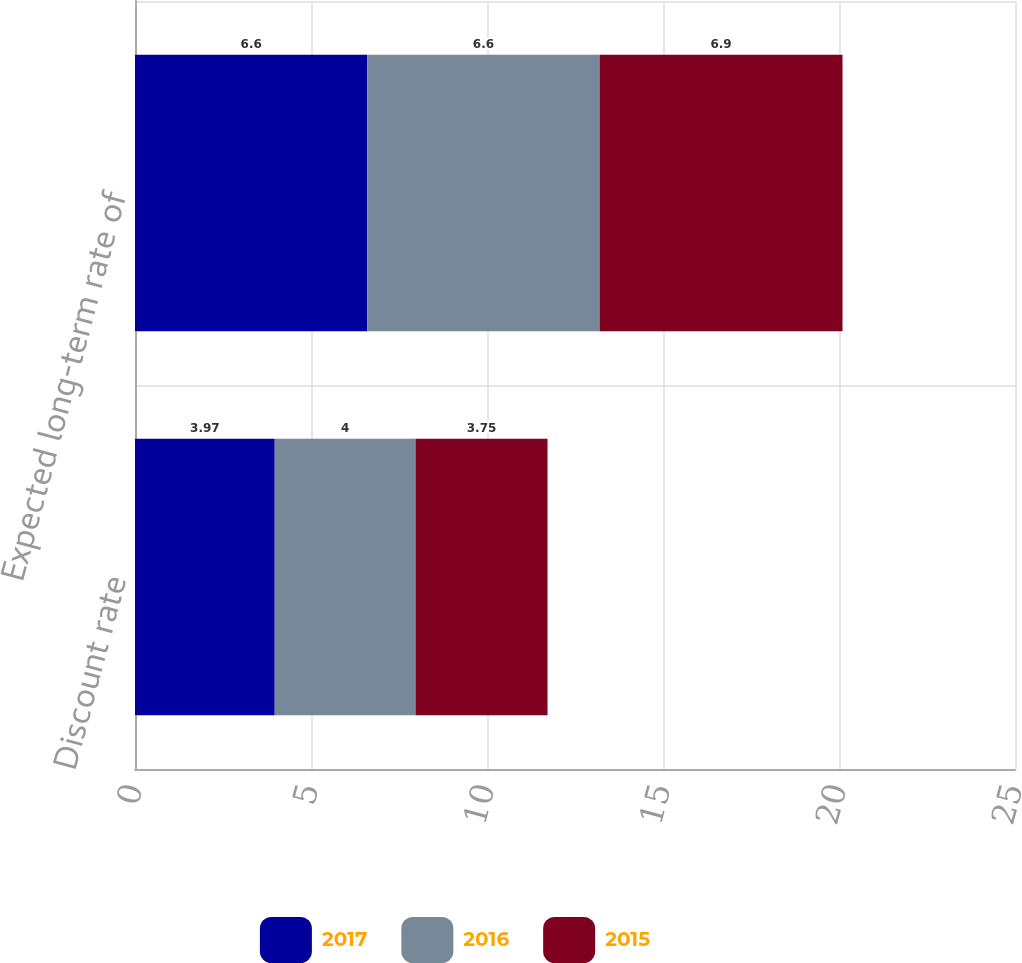Convert chart. <chart><loc_0><loc_0><loc_500><loc_500><stacked_bar_chart><ecel><fcel>Discount rate<fcel>Expected long-term rate of<nl><fcel>2017<fcel>3.97<fcel>6.6<nl><fcel>2016<fcel>4<fcel>6.6<nl><fcel>2015<fcel>3.75<fcel>6.9<nl></chart> 